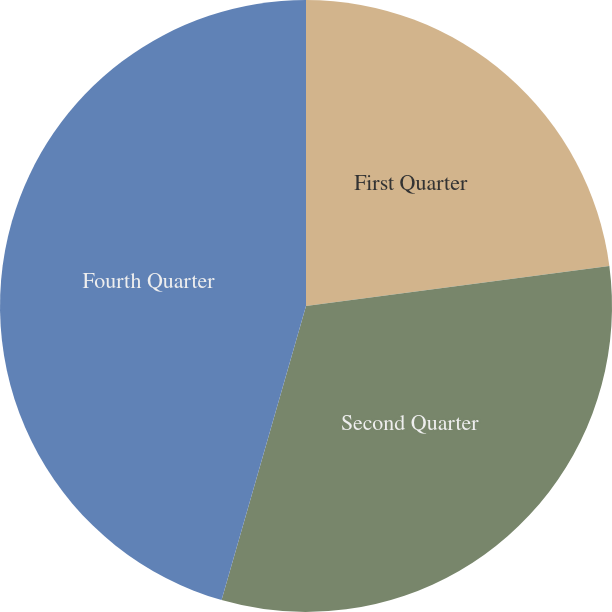Convert chart to OTSL. <chart><loc_0><loc_0><loc_500><loc_500><pie_chart><fcel>First Quarter<fcel>Second Quarter<fcel>Fourth Quarter<nl><fcel>22.91%<fcel>31.54%<fcel>45.55%<nl></chart> 